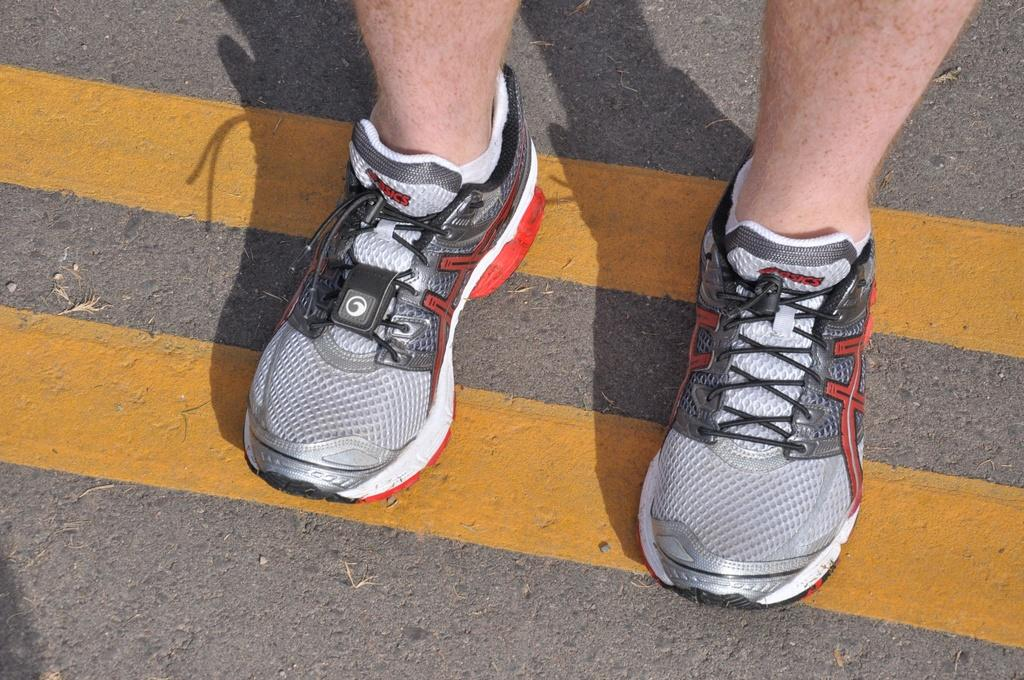What is the main subject in the image? The main subject in the image is a road. What is a specific feature of the road? The road has yellow color lines. What else can be seen on the road? There are person's legs with shoes visible on the road. What type of answer can be seen hanging from the branch in the image? There is no branch or answer present in the image. 